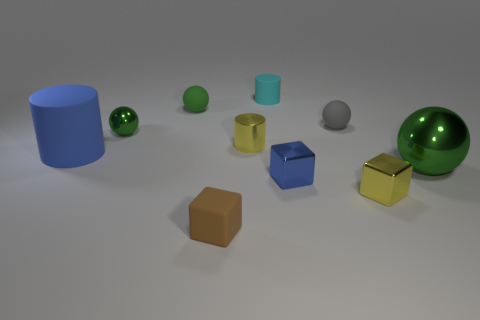What textures are visible on the objects in this scene? Most of the objects exhibit a smooth texture. However, the reflective sheen on the green metallic ball and the yellow cube suggests a polished surface, while the blue cylinder, matte green ball, and teal cylinder appear to have a more diffused, matte texture. 